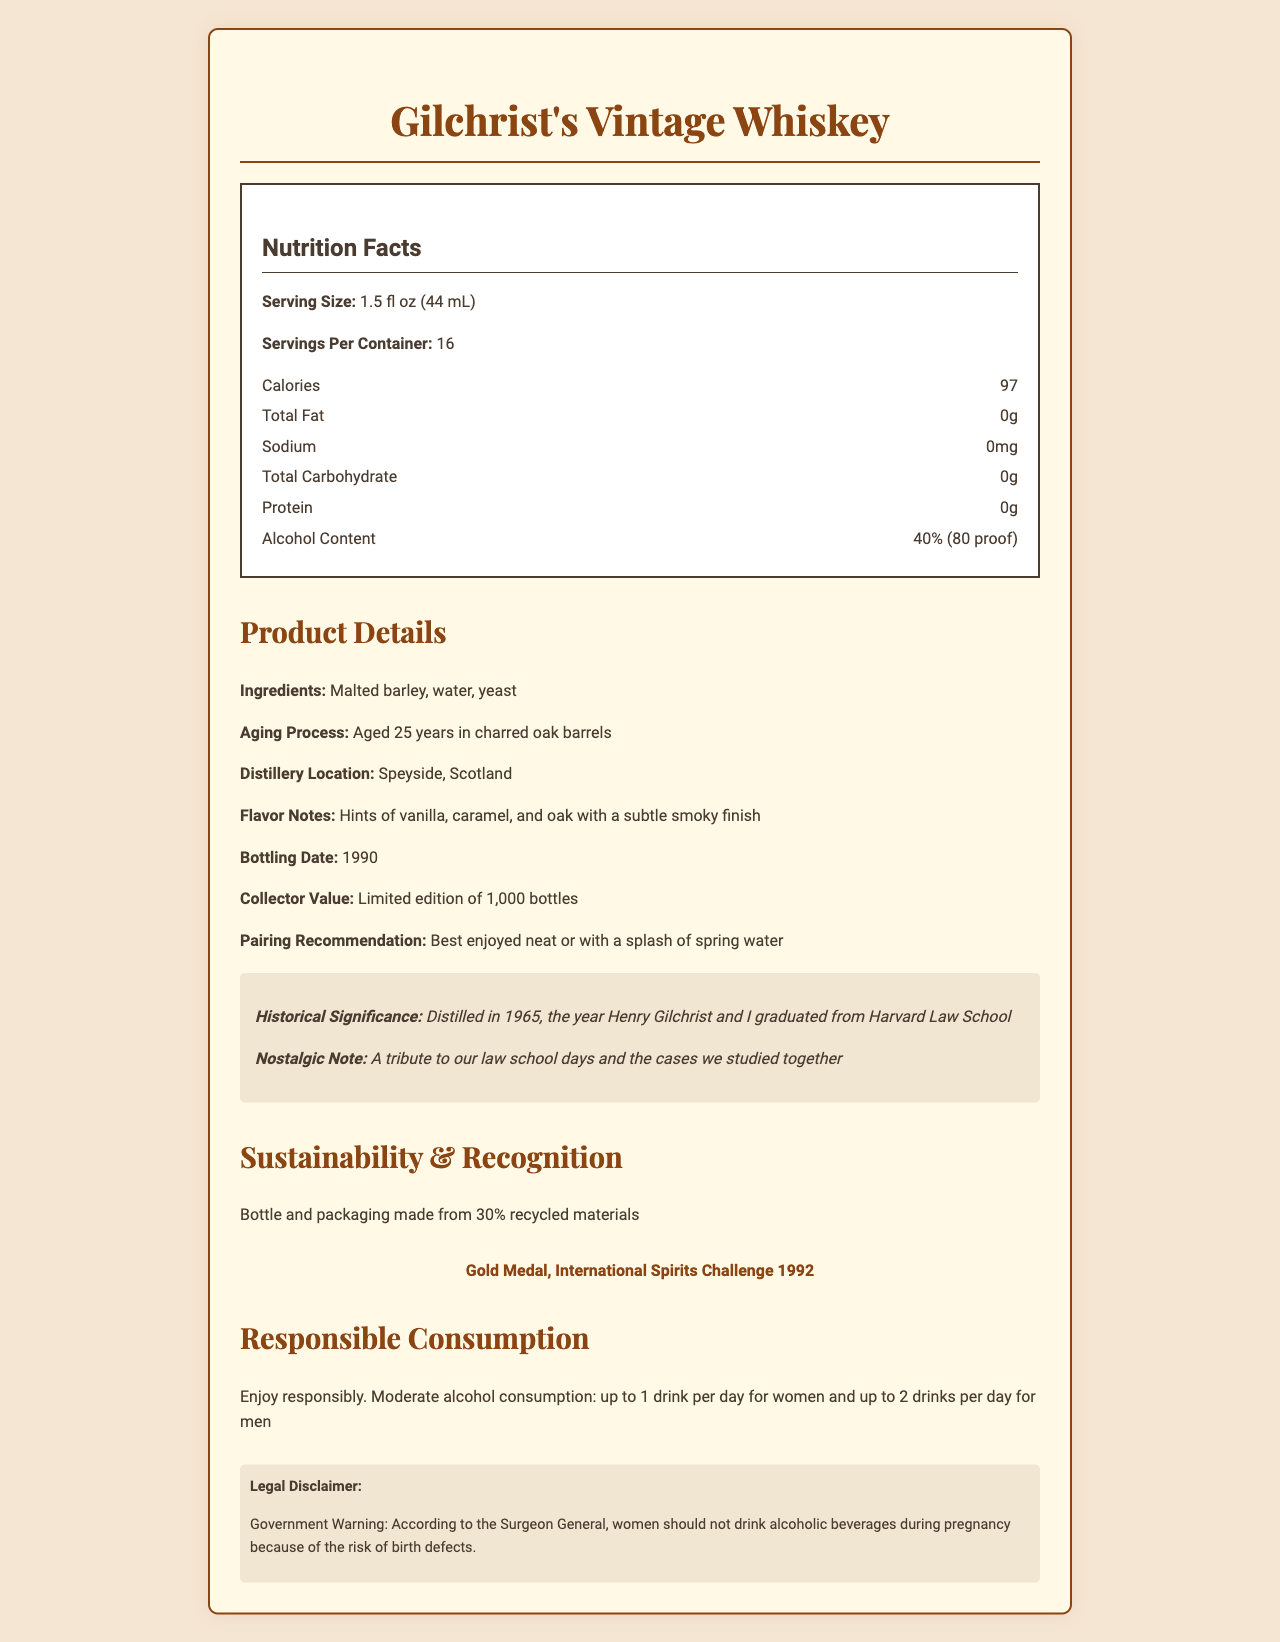what is the serving size of Gilchrist's Vintage Whiskey? The serving size is clearly stated under the Nutrition Facts section as "1.5 fl oz (44 mL)".
Answer: 1.5 fl oz (44 mL) how many servings are in one container of this whiskey? The document states "Servings Per Container: 16" under Nutrition Facts.
Answer: 16 how many calories are in one serving? The document lists "Calories: 97" under the Nutrition Facts section.
Answer: 97 what are the ingredients of Gilchrist's Vintage Whiskey? The ingredients are listed under the Product Details section as "Malted barley, water, yeast".
Answer: Malted barley, water, yeast what is the alcohol content of this whiskey? The alcohol content is specified under the Nutrition Facts section as "40% (80 proof)".
Answer: 40% (80 proof) where was this whiskey distilled? The distillery location is given as "Speyside, Scotland" under the Product Details section.
Answer: Speyside, Scotland when was Gilchrist's Vintage Whiskey bottled? Under Product Details, it states "Bottling Date: 1990".
Answer: 1990 how many gold medals did this whiskey win at the International Spirits Challenge? The document mentions "Gold Medal, International Spirits Challenge 1992" under Sustainability & Recognition.
Answer: 1 which year was significant in the historical context of this whiskey? A. 1965 B. 1990 C. 1992 The document notes the historical significance as "Distilled in 1965, the year Henry Gilchrist and I graduated from Harvard Law School".
Answer: A. 1965 what is not an ingredient of Gilchrist's Vintage Whiskey? A. Malted barley B. Yeast C. Sugar D. Water The ingredients listed are "Malted barley, water, yeast"; sugar is not mentioned.
Answer: C. Sugar is enjoying this whiskey responsibly emphasized in the document? The document includes a moderate consumption statement that emphasizes responsible consumption.
Answer: Yes summarize the main idea of the Gilchrist's Vintage Whiskey document. The document details the serving size, calorie content, ingredients, alcohol content, aging process, and historical significance, along with sustainability information and recognitions. It highlights responsible consumption as well.
Answer: The document describes the nutritional facts, historical significance, and product details of Gilchrist's Vintage Whiskey, emphasizing its moderate alcohol content, quality, and sustainability. how long was this whiskey aged? The document states "Aged 25 years in charred oak barrels" under Product Details.
Answer: 25 years what flavor notes are associated with this whiskey? The flavor notes are listed under Product Details as "Hints of vanilla, caramel, and oak with a subtle smoky finish".
Answer: Hints of vanilla, caramel, and oak with a subtle smoky finish how many bottles were produced in this limited edition? The collector value section under Product Details states a "Limited edition of 1,000 bottles".
Answer: 1,000 bottles was this whiskey distilled on the same date as it was bottled? The whiskey was distilled in 1965 and bottled in 1990, clearly indicating different dates.
Answer: No what legal disclaimer is given about consuming this whiskey during pregnancy? The legal disclaimer section of the document states this exact warning.
Answer: According to the Surgeon General, women should not drink alcoholic beverages during pregnancy because of the risk of birth defects. what was the main field of study for Henry Gilchrist and his classmate? The field of study is not explicitly mentioned in the visual document, though it hints at law school.
Answer: I don't know 